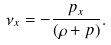<formula> <loc_0><loc_0><loc_500><loc_500>\nu _ { x } = - \frac { p _ { x } } { ( \rho + p ) } .</formula> 